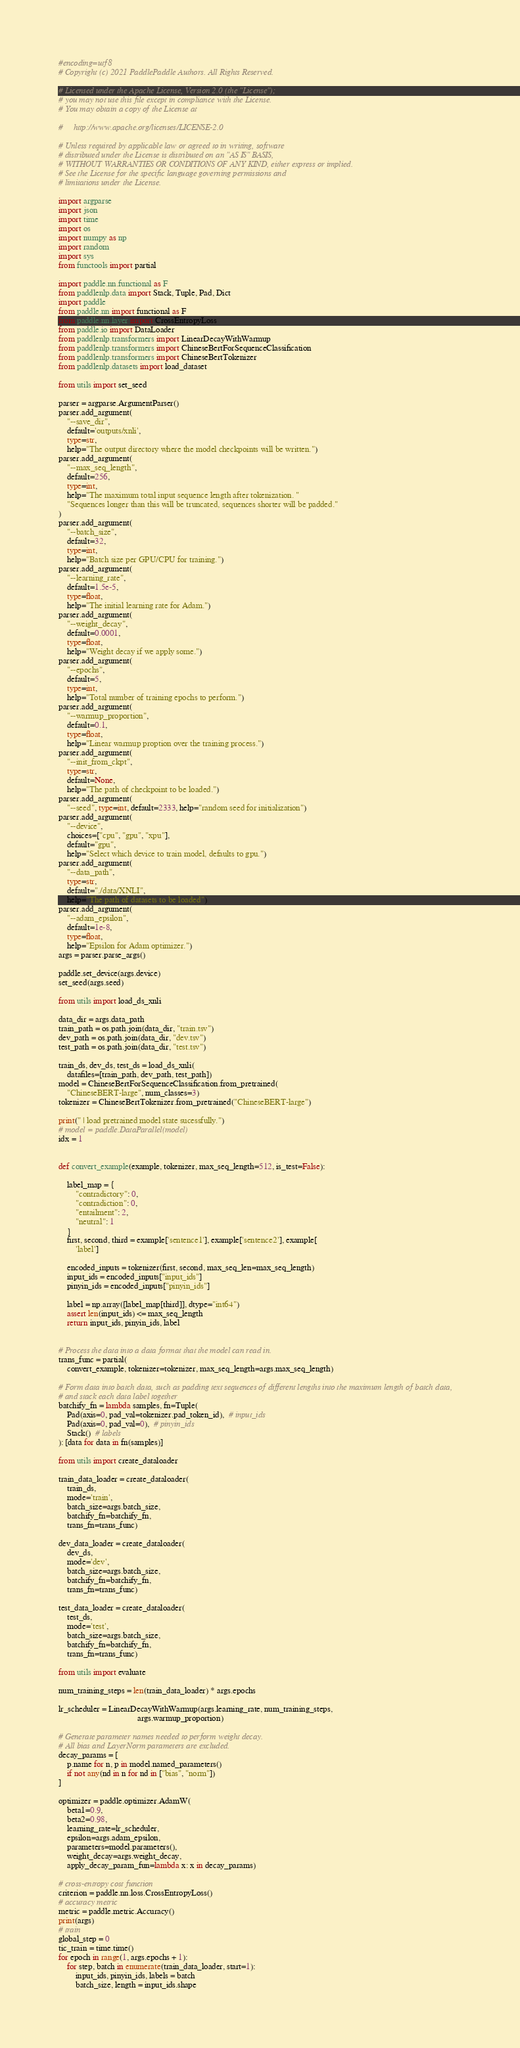<code> <loc_0><loc_0><loc_500><loc_500><_Python_>#encoding=utf8
# Copyright (c) 2021 PaddlePaddle Authors. All Rights Reserved.

# Licensed under the Apache License, Version 2.0 (the "License");
# you may not use this file except in compliance with the License.
# You may obtain a copy of the License at

#     http://www.apache.org/licenses/LICENSE-2.0

# Unless required by applicable law or agreed to in writing, software
# distributed under the License is distributed on an "AS IS" BASIS,
# WITHOUT WARRANTIES OR CONDITIONS OF ANY KIND, either express or implied.
# See the License for the specific language governing permissions and
# limitations under the License.

import argparse
import json
import time
import os
import numpy as np
import random
import sys
from functools import partial

import paddle.nn.functional as F
from paddlenlp.data import Stack, Tuple, Pad, Dict
import paddle
from paddle.nn import functional as F
from paddle.nn.layer import CrossEntropyLoss
from paddle.io import DataLoader
from paddlenlp.transformers import LinearDecayWithWarmup
from paddlenlp.transformers import ChineseBertForSequenceClassification
from paddlenlp.transformers import ChineseBertTokenizer
from paddlenlp.datasets import load_dataset

from utils import set_seed

parser = argparse.ArgumentParser()
parser.add_argument(
    "--save_dir",
    default='outputs/xnli',
    type=str,
    help="The output directory where the model checkpoints will be written.")
parser.add_argument(
    "--max_seq_length",
    default=256,
    type=int,
    help="The maximum total input sequence length after tokenization. "
    "Sequences longer than this will be truncated, sequences shorter will be padded."
)
parser.add_argument(
    "--batch_size",
    default=32,
    type=int,
    help="Batch size per GPU/CPU for training.")
parser.add_argument(
    "--learning_rate",
    default=1.5e-5,
    type=float,
    help="The initial learning rate for Adam.")
parser.add_argument(
    "--weight_decay",
    default=0.0001,
    type=float,
    help="Weight decay if we apply some.")
parser.add_argument(
    "--epochs",
    default=5,
    type=int,
    help="Total number of training epochs to perform.")
parser.add_argument(
    "--warmup_proportion",
    default=0.1,
    type=float,
    help="Linear warmup proption over the training process.")
parser.add_argument(
    "--init_from_ckpt",
    type=str,
    default=None,
    help="The path of checkpoint to be loaded.")
parser.add_argument(
    "--seed", type=int, default=2333, help="random seed for initialization")
parser.add_argument(
    "--device",
    choices=["cpu", "gpu", "xpu"],
    default="gpu",
    help="Select which device to train model, defaults to gpu.")
parser.add_argument(
    "--data_path",
    type=str,
    default="./data/XNLI",
    help="The path of datasets to be loaded")
parser.add_argument(
    "--adam_epsilon",
    default=1e-8,
    type=float,
    help="Epsilon for Adam optimizer.")
args = parser.parse_args()

paddle.set_device(args.device)
set_seed(args.seed)

from utils import load_ds_xnli

data_dir = args.data_path
train_path = os.path.join(data_dir, "train.tsv")
dev_path = os.path.join(data_dir, "dev.tsv")
test_path = os.path.join(data_dir, "test.tsv")

train_ds, dev_ds, test_ds = load_ds_xnli(
    datafiles=[train_path, dev_path, test_path])
model = ChineseBertForSequenceClassification.from_pretrained(
    "ChineseBERT-large", num_classes=3)
tokenizer = ChineseBertTokenizer.from_pretrained("ChineseBERT-large")

print(" | load pretrained model state sucessfully.")
# model = paddle.DataParallel(model)
idx = 1


def convert_example(example, tokenizer, max_seq_length=512, is_test=False):

    label_map = {
        "contradictory": 0,
        "contradiction": 0,
        "entailment": 2,
        "neutral": 1
    }
    first, second, third = example['sentence1'], example['sentence2'], example[
        'label']

    encoded_inputs = tokenizer(first, second, max_seq_len=max_seq_length)
    input_ids = encoded_inputs["input_ids"]
    pinyin_ids = encoded_inputs["pinyin_ids"]

    label = np.array([label_map[third]], dtype="int64")
    assert len(input_ids) <= max_seq_length
    return input_ids, pinyin_ids, label


# Process the data into a data format that the model can read in.
trans_func = partial(
    convert_example, tokenizer=tokenizer, max_seq_length=args.max_seq_length)

# Form data into batch data, such as padding text sequences of different lengths into the maximum length of batch data, 
# and stack each data label together
batchify_fn = lambda samples, fn=Tuple(
    Pad(axis=0, pad_val=tokenizer.pad_token_id),  # input_ids
    Pad(axis=0, pad_val=0),  # pinyin_ids
    Stack()  # labels
): [data for data in fn(samples)]

from utils import create_dataloader

train_data_loader = create_dataloader(
    train_ds,
    mode='train',
    batch_size=args.batch_size,
    batchify_fn=batchify_fn,
    trans_fn=trans_func)

dev_data_loader = create_dataloader(
    dev_ds,
    mode='dev',
    batch_size=args.batch_size,
    batchify_fn=batchify_fn,
    trans_fn=trans_func)

test_data_loader = create_dataloader(
    test_ds,
    mode='test',
    batch_size=args.batch_size,
    batchify_fn=batchify_fn,
    trans_fn=trans_func)

from utils import evaluate

num_training_steps = len(train_data_loader) * args.epochs

lr_scheduler = LinearDecayWithWarmup(args.learning_rate, num_training_steps,
                                     args.warmup_proportion)

# Generate parameter names needed to perform weight decay.
# All bias and LayerNorm parameters are excluded.
decay_params = [
    p.name for n, p in model.named_parameters()
    if not any(nd in n for nd in ["bias", "norm"])
]

optimizer = paddle.optimizer.AdamW(
    beta1=0.9,
    beta2=0.98,
    learning_rate=lr_scheduler,
    epsilon=args.adam_epsilon,
    parameters=model.parameters(),
    weight_decay=args.weight_decay,
    apply_decay_param_fun=lambda x: x in decay_params)

# cross-entropy cost function
criterion = paddle.nn.loss.CrossEntropyLoss()
# accuracy metric
metric = paddle.metric.Accuracy()
print(args)
# train
global_step = 0
tic_train = time.time()
for epoch in range(1, args.epochs + 1):
    for step, batch in enumerate(train_data_loader, start=1):
        input_ids, pinyin_ids, labels = batch
        batch_size, length = input_ids.shape</code> 